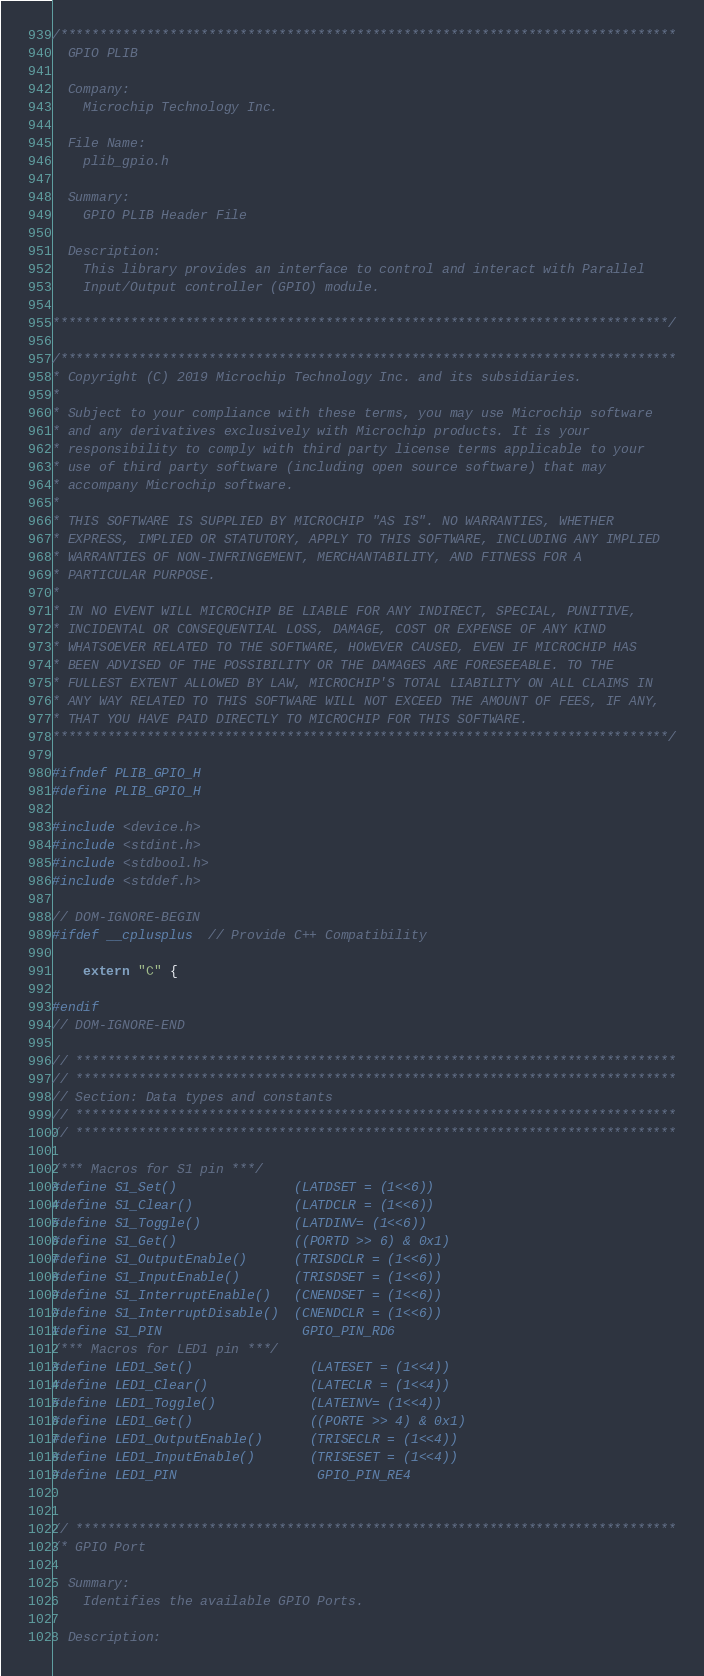Convert code to text. <code><loc_0><loc_0><loc_500><loc_500><_C_>/*******************************************************************************
  GPIO PLIB

  Company:
    Microchip Technology Inc.

  File Name:
    plib_gpio.h

  Summary:
    GPIO PLIB Header File

  Description:
    This library provides an interface to control and interact with Parallel
    Input/Output controller (GPIO) module.

*******************************************************************************/

/*******************************************************************************
* Copyright (C) 2019 Microchip Technology Inc. and its subsidiaries.
*
* Subject to your compliance with these terms, you may use Microchip software
* and any derivatives exclusively with Microchip products. It is your
* responsibility to comply with third party license terms applicable to your
* use of third party software (including open source software) that may
* accompany Microchip software.
*
* THIS SOFTWARE IS SUPPLIED BY MICROCHIP "AS IS". NO WARRANTIES, WHETHER
* EXPRESS, IMPLIED OR STATUTORY, APPLY TO THIS SOFTWARE, INCLUDING ANY IMPLIED
* WARRANTIES OF NON-INFRINGEMENT, MERCHANTABILITY, AND FITNESS FOR A
* PARTICULAR PURPOSE.
*
* IN NO EVENT WILL MICROCHIP BE LIABLE FOR ANY INDIRECT, SPECIAL, PUNITIVE,
* INCIDENTAL OR CONSEQUENTIAL LOSS, DAMAGE, COST OR EXPENSE OF ANY KIND
* WHATSOEVER RELATED TO THE SOFTWARE, HOWEVER CAUSED, EVEN IF MICROCHIP HAS
* BEEN ADVISED OF THE POSSIBILITY OR THE DAMAGES ARE FORESEEABLE. TO THE
* FULLEST EXTENT ALLOWED BY LAW, MICROCHIP'S TOTAL LIABILITY ON ALL CLAIMS IN
* ANY WAY RELATED TO THIS SOFTWARE WILL NOT EXCEED THE AMOUNT OF FEES, IF ANY,
* THAT YOU HAVE PAID DIRECTLY TO MICROCHIP FOR THIS SOFTWARE.
*******************************************************************************/

#ifndef PLIB_GPIO_H
#define PLIB_GPIO_H

#include <device.h>
#include <stdint.h>
#include <stdbool.h>
#include <stddef.h>

// DOM-IGNORE-BEGIN
#ifdef __cplusplus  // Provide C++ Compatibility

    extern "C" {

#endif
// DOM-IGNORE-END

// *****************************************************************************
// *****************************************************************************
// Section: Data types and constants
// *****************************************************************************
// *****************************************************************************

/*** Macros for S1 pin ***/
#define S1_Set()               (LATDSET = (1<<6))
#define S1_Clear()             (LATDCLR = (1<<6))
#define S1_Toggle()            (LATDINV= (1<<6))
#define S1_Get()               ((PORTD >> 6) & 0x1)
#define S1_OutputEnable()      (TRISDCLR = (1<<6))
#define S1_InputEnable()       (TRISDSET = (1<<6))
#define S1_InterruptEnable()   (CNENDSET = (1<<6))
#define S1_InterruptDisable()  (CNENDCLR = (1<<6))
#define S1_PIN                  GPIO_PIN_RD6
/*** Macros for LED1 pin ***/
#define LED1_Set()               (LATESET = (1<<4))
#define LED1_Clear()             (LATECLR = (1<<4))
#define LED1_Toggle()            (LATEINV= (1<<4))
#define LED1_Get()               ((PORTE >> 4) & 0x1)
#define LED1_OutputEnable()      (TRISECLR = (1<<4))
#define LED1_InputEnable()       (TRISESET = (1<<4))
#define LED1_PIN                  GPIO_PIN_RE4


// *****************************************************************************
/* GPIO Port

  Summary:
    Identifies the available GPIO Ports.

  Description:</code> 